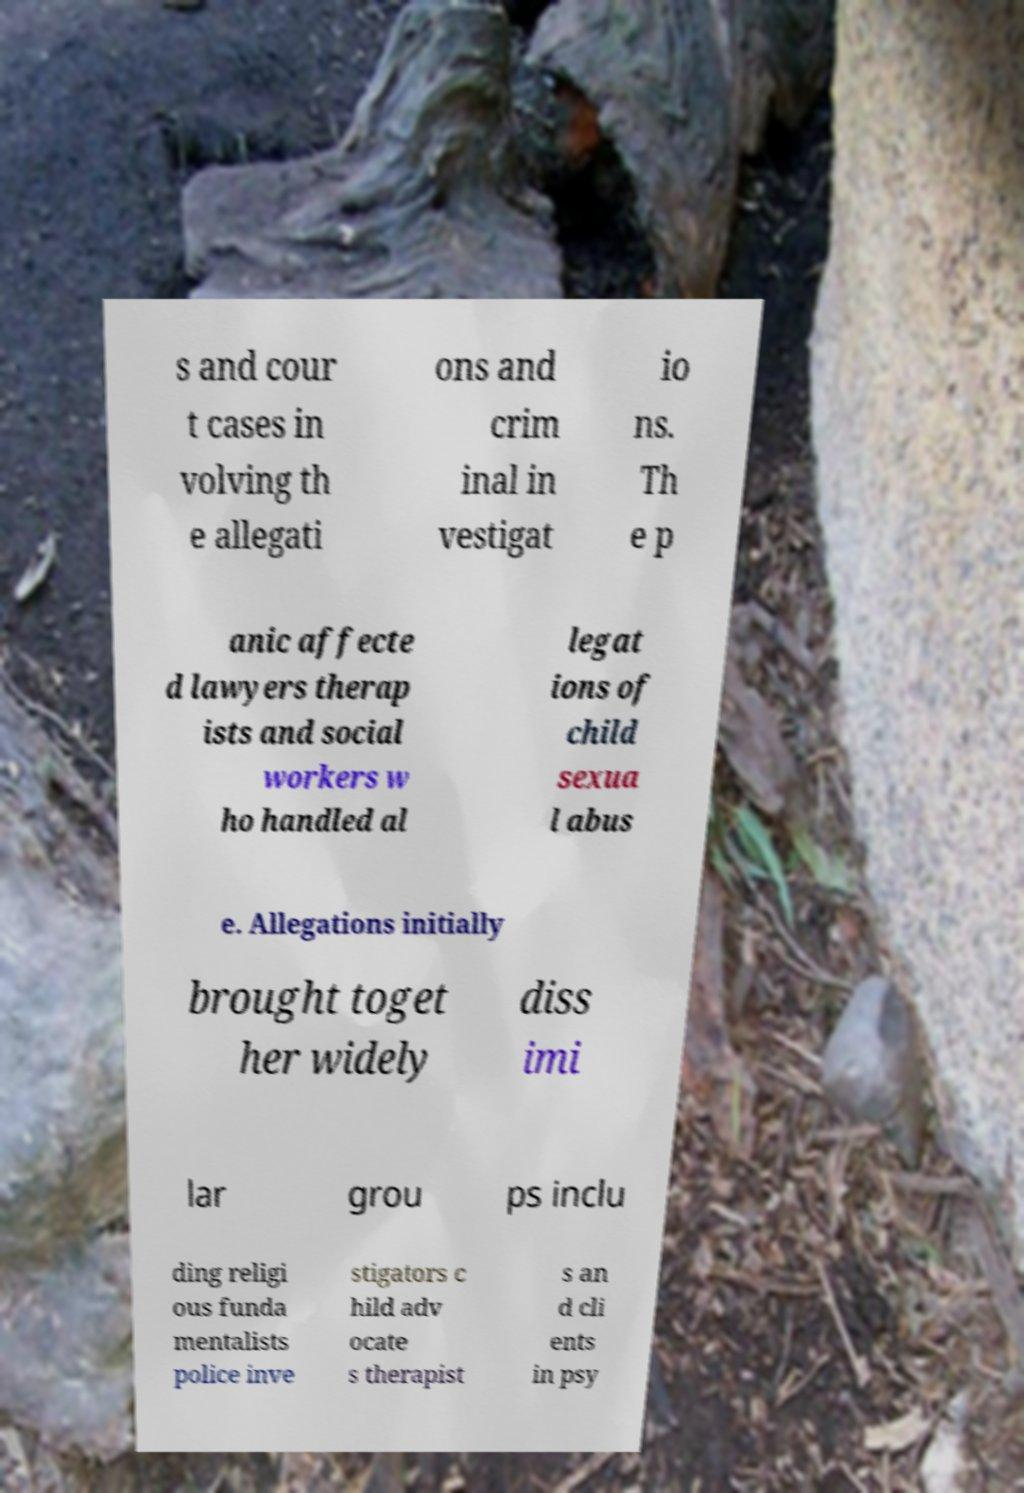Could you extract and type out the text from this image? s and cour t cases in volving th e allegati ons and crim inal in vestigat io ns. Th e p anic affecte d lawyers therap ists and social workers w ho handled al legat ions of child sexua l abus e. Allegations initially brought toget her widely diss imi lar grou ps inclu ding religi ous funda mentalists police inve stigators c hild adv ocate s therapist s an d cli ents in psy 